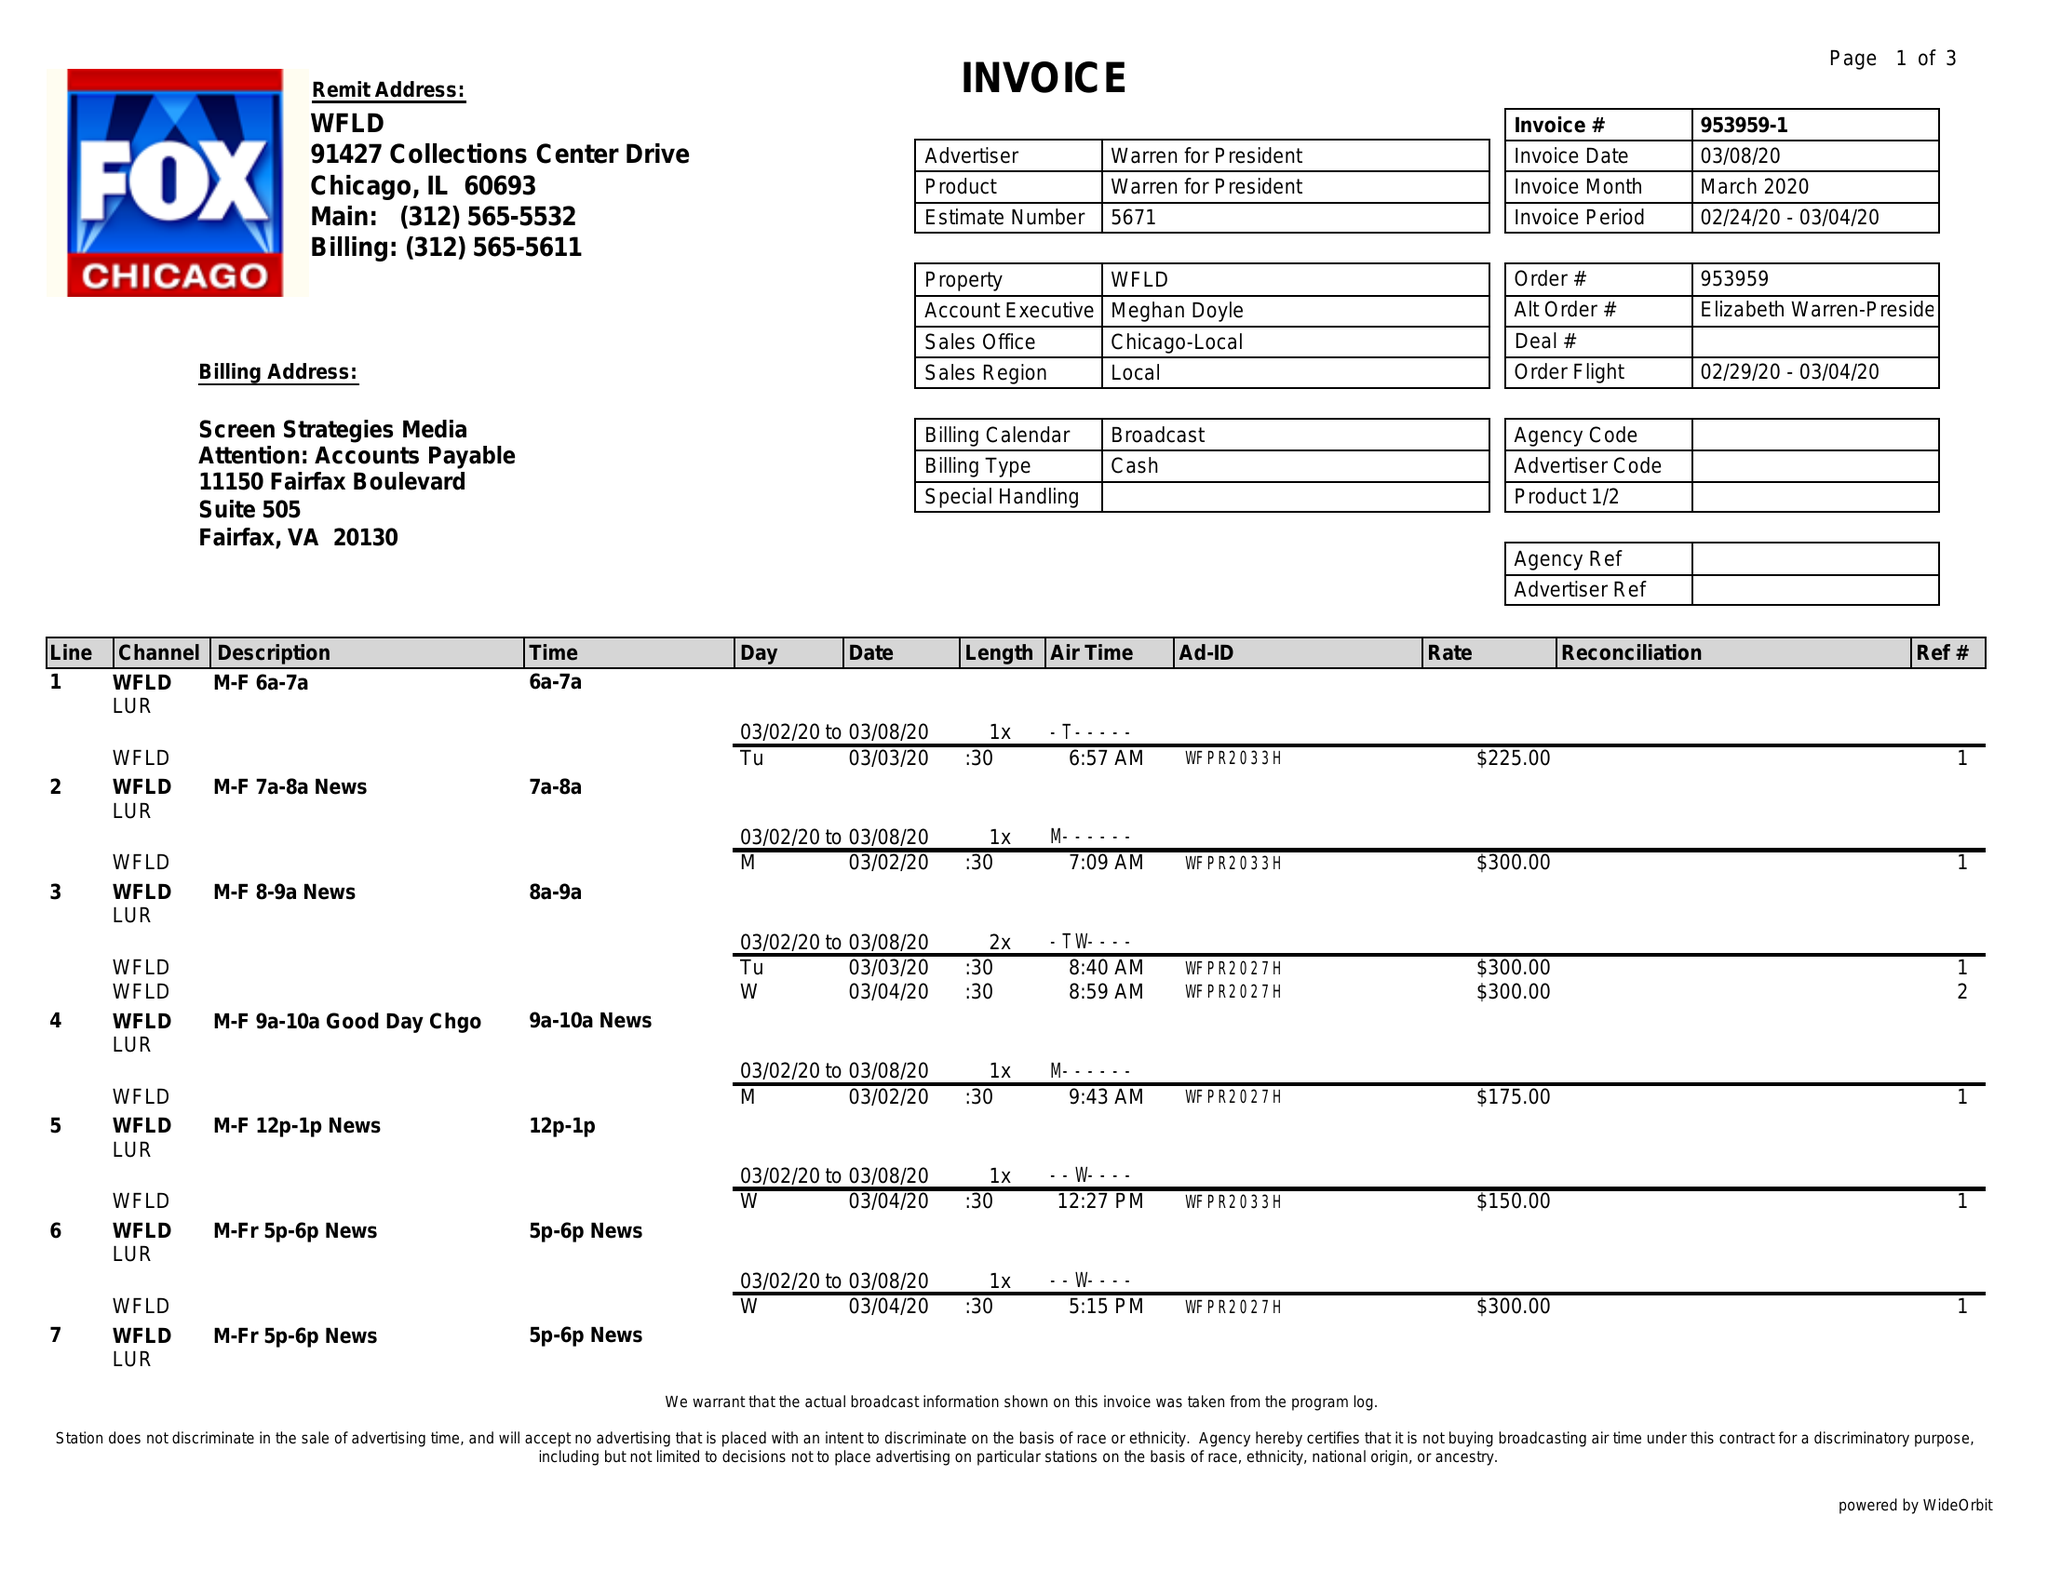What is the value for the contract_num?
Answer the question using a single word or phrase. 953959 